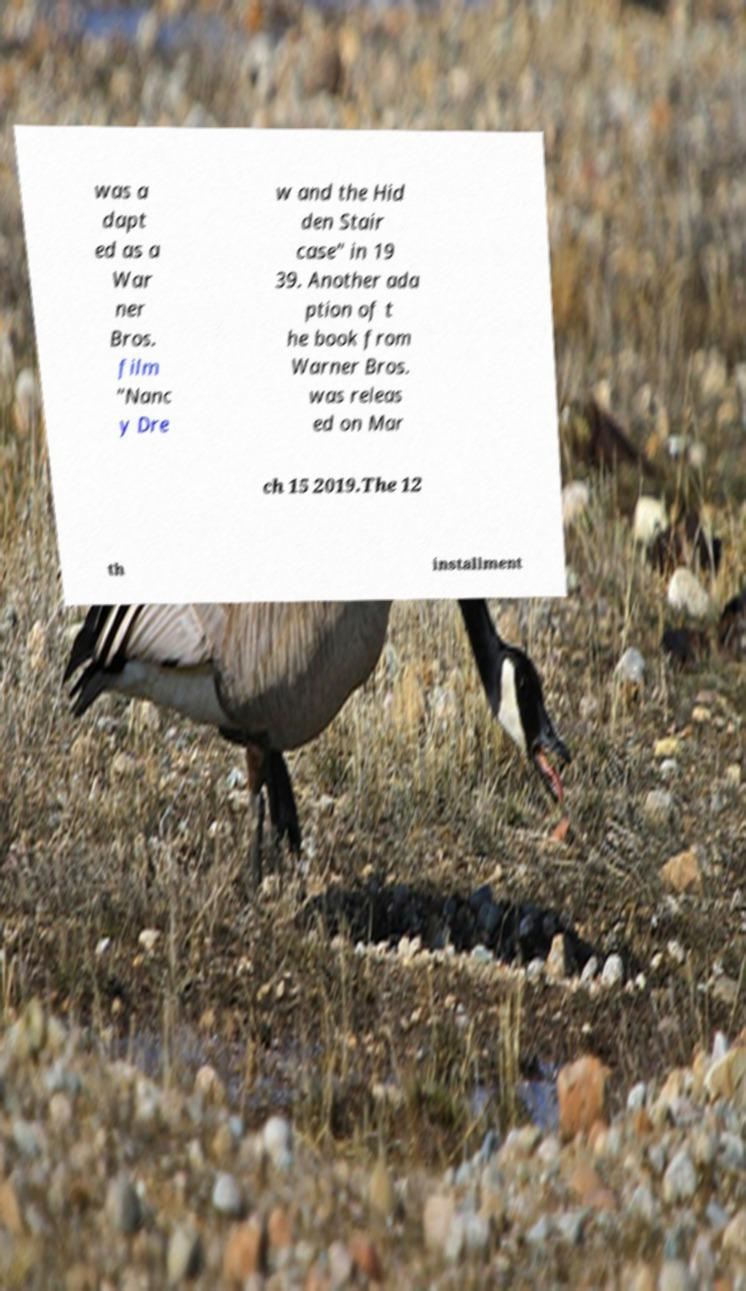Can you read and provide the text displayed in the image?This photo seems to have some interesting text. Can you extract and type it out for me? was a dapt ed as a War ner Bros. film "Nanc y Dre w and the Hid den Stair case" in 19 39. Another ada ption of t he book from Warner Bros. was releas ed on Mar ch 15 2019.The 12 th installment 